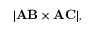Convert formula to latex. <formula><loc_0><loc_0><loc_500><loc_500>| A B \times A C | ,</formula> 